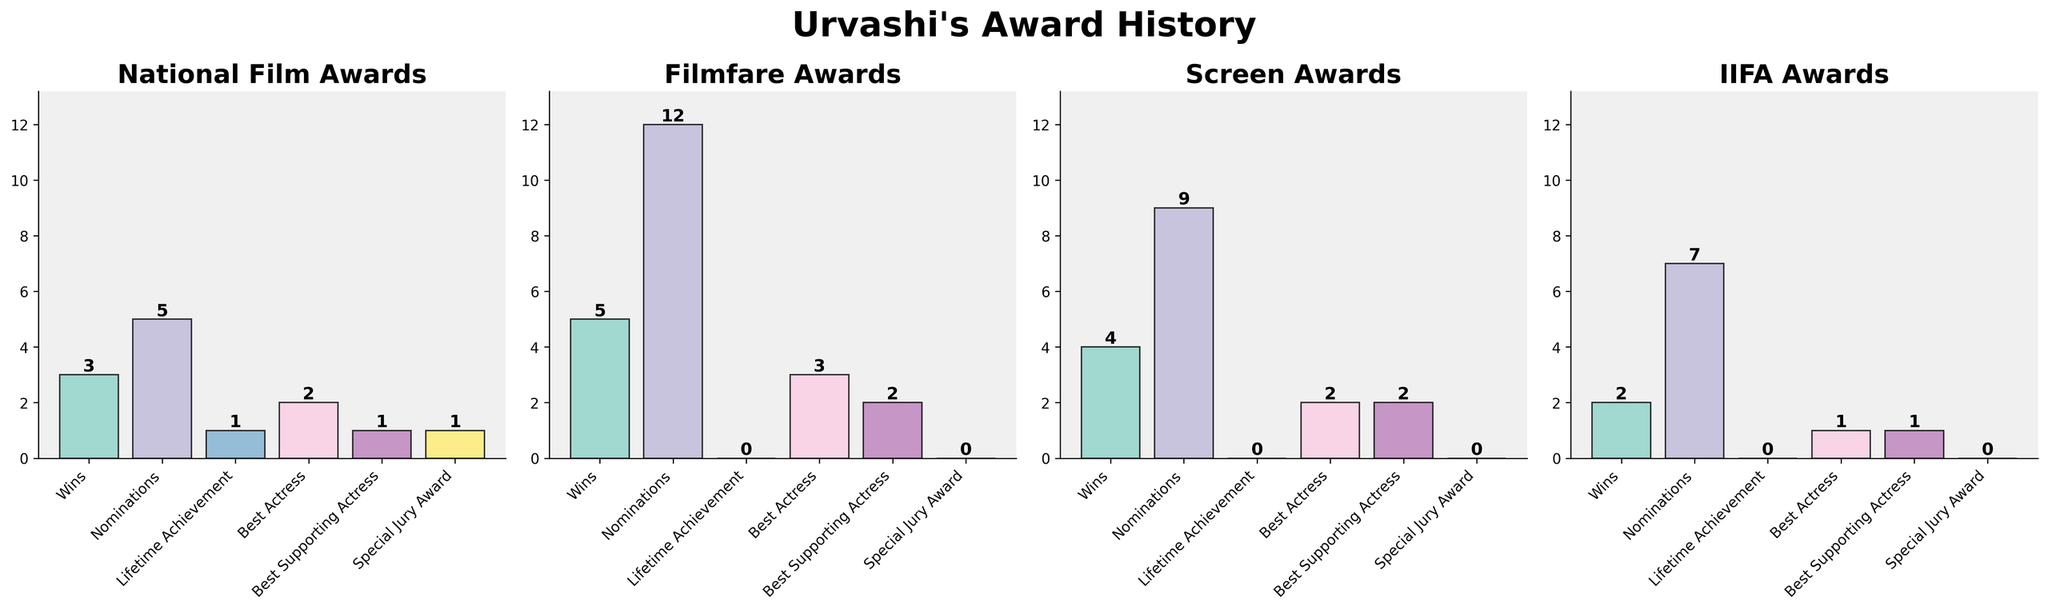Which award ceremony had the most wins for Urvashi? By examining the height of the bars in the "Wins" category, it's clear that the Filmfare Awards has the tallest bar. Hence, Urvashi has the most wins there.
Answer: Filmfare Awards How many total awards has Urvashi received across all ceremonies (including wins, lifetime achievements, etc.)? To find the total, we need to sum all the numbers in each subplot. National Film Awards: 3+5+1+2+1+1=13, Filmfare Awards: 5+12+0+3+2+0=22, Screen Awards: 4+9+0+2+2+0=17, IIFA Awards: 2+7+0+1+1+0=11. Total = 13+22+17+11 = 63
Answer: 63 Which category has the lowest number of nominations across all award ceremonies? By comparing the height of the bars in the "Nominations" category across all subplots, it is evident that the lowest bar is in the IIFA Awards category with a count of 7.
Answer: IIFA Awards In which category did Urvashi receive the same number of awards in both National Film Awards and Filmfare Awards? Looking at the heights of the bars, we see that the "Best Supporting Actress" category has the same height in both the National Film Awards and Filmfare Awards subplots, each having a count of 1.
Answer: Best Supporting Actress Compare the total number of wins and nominations for Urvashi. Which is greater, and by how much? Summing Wins: 3+5+4+2=14 and Nominations: 5+12+9+7=33. The difference is 33 - 14 = 19, indicating there are more nominations than wins.
Answer: Nominations by 19 How many categories show no awards in the Filmfare Awards subplot? Observing the Filmfare Awards subplot, we see categories "Lifetime Achievement" and "Special Jury Award" both have 0 awards.
Answer: 2 Which award category does Urvashi have only one award in for the National Film Awards? Looking at the National Film Awards subplot, we find that the "Best Supporting Actress" and "Special Jury Award" categories each have a height of 1.
Answer: Best Supporting Actress, Special Jury Award What's the total number of Best Actress awards Urvashi has received across all ceremonies? Summing the values for the "Best Actress" category: 2+3+2+1=8
Answer: 8 